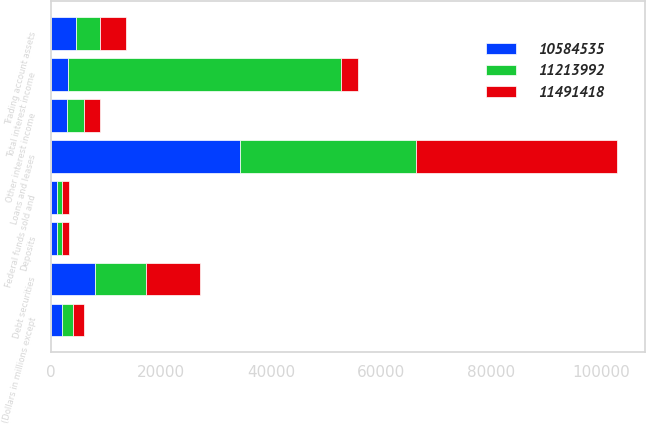<chart> <loc_0><loc_0><loc_500><loc_500><stacked_bar_chart><ecel><fcel>(Dollars in millions except<fcel>Loans and leases<fcel>Debt securities<fcel>Federal funds sold and<fcel>Trading account assets<fcel>Other interest income<fcel>Total interest income<fcel>Deposits<nl><fcel>1.1214e+07<fcel>2015<fcel>32070<fcel>9319<fcel>988<fcel>4397<fcel>3026<fcel>49800<fcel>861<nl><fcel>1.05845e+07<fcel>2014<fcel>34307<fcel>8021<fcel>1039<fcel>4561<fcel>2958<fcel>2992<fcel>1080<nl><fcel>1.14914e+07<fcel>2013<fcel>36470<fcel>9749<fcel>1229<fcel>4706<fcel>2866<fcel>2992<fcel>1396<nl></chart> 